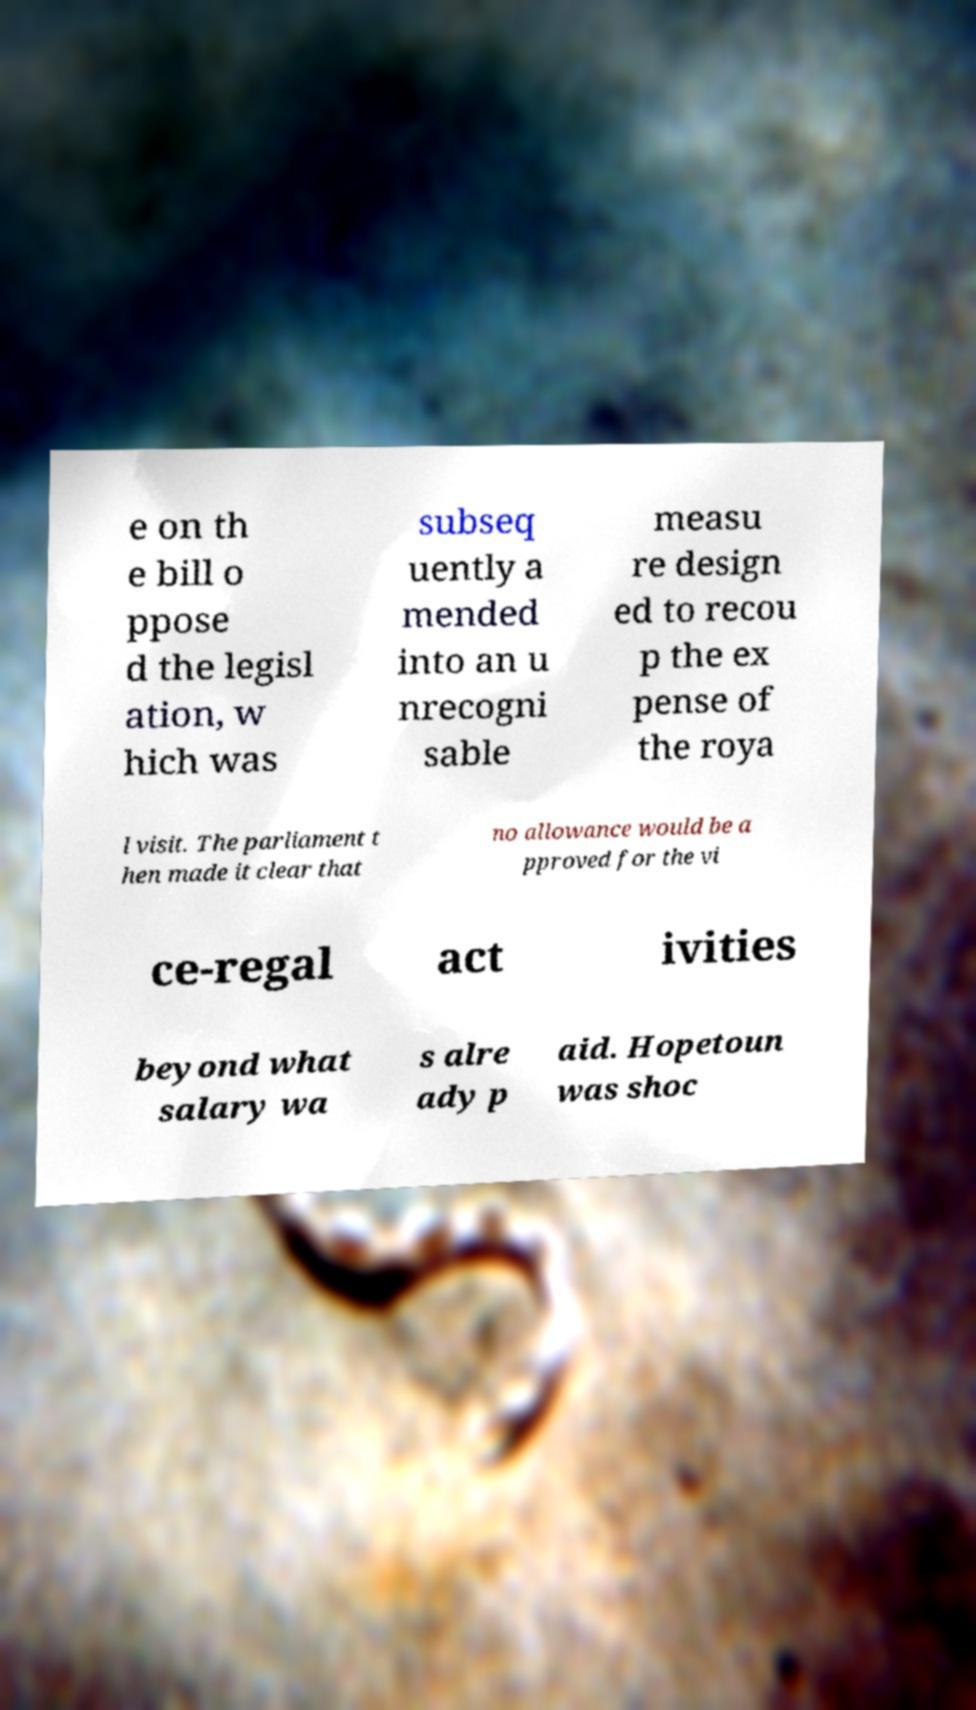Please read and relay the text visible in this image. What does it say? e on th e bill o ppose d the legisl ation, w hich was subseq uently a mended into an u nrecogni sable measu re design ed to recou p the ex pense of the roya l visit. The parliament t hen made it clear that no allowance would be a pproved for the vi ce-regal act ivities beyond what salary wa s alre ady p aid. Hopetoun was shoc 